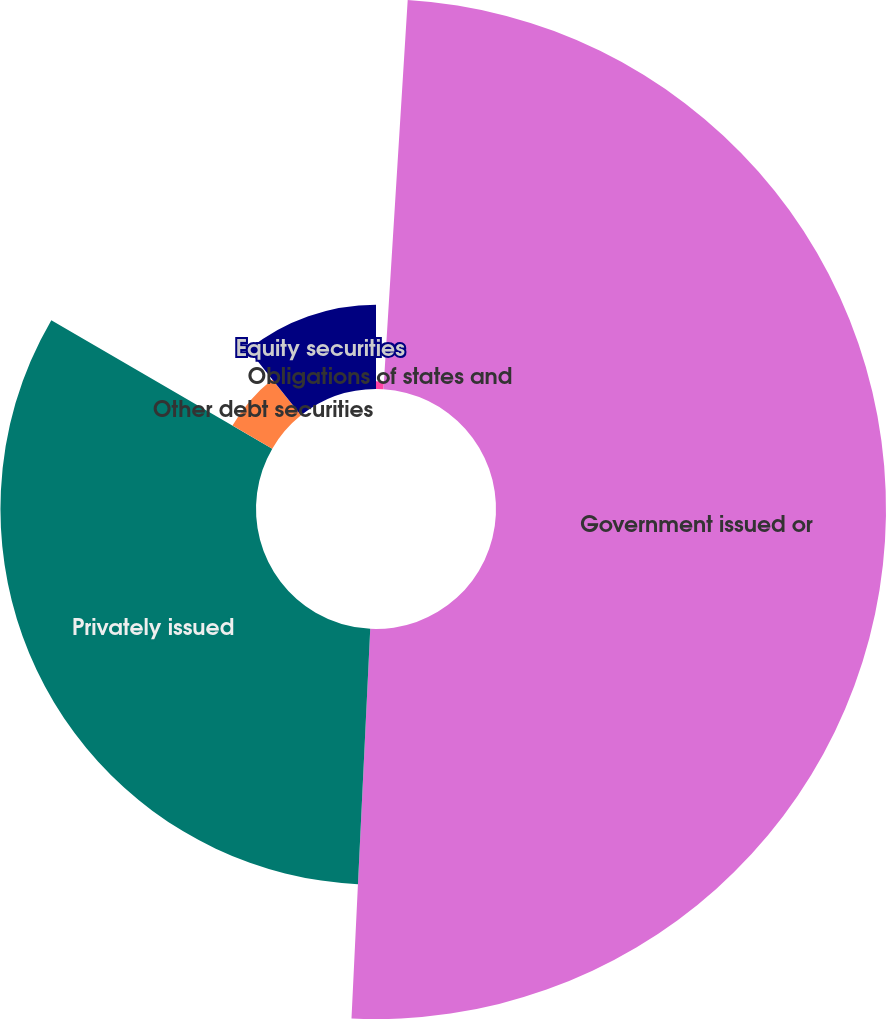Convert chart to OTSL. <chart><loc_0><loc_0><loc_500><loc_500><pie_chart><fcel>Obligations of states and<fcel>Government issued or<fcel>Privately issued<fcel>Other debt securities<fcel>Equity securities<nl><fcel>0.99%<fcel>49.78%<fcel>32.62%<fcel>5.87%<fcel>10.75%<nl></chart> 